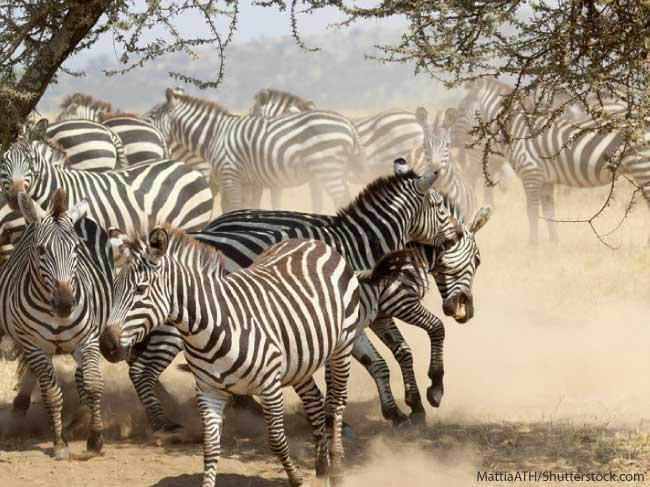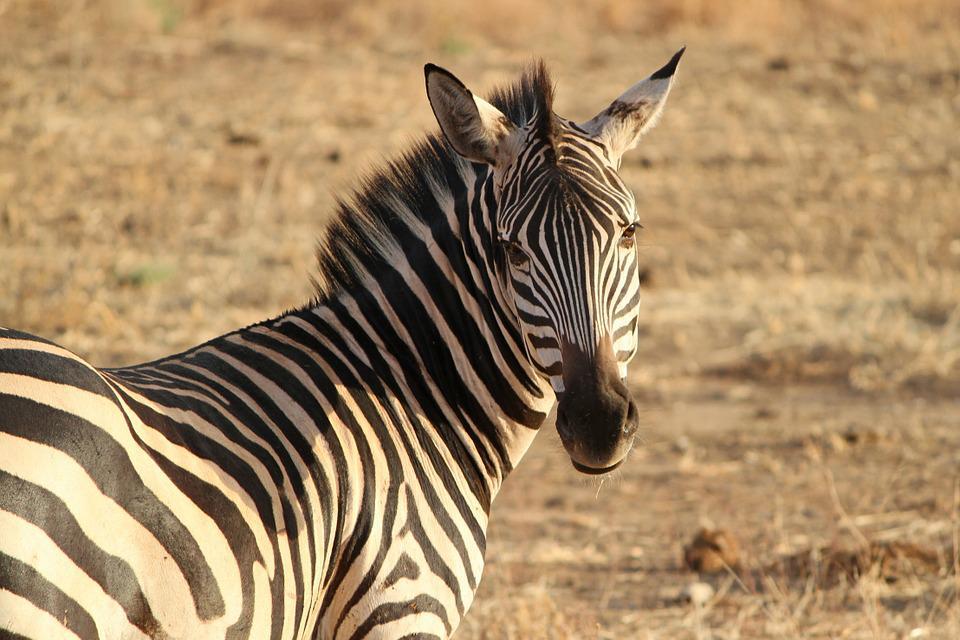The first image is the image on the left, the second image is the image on the right. For the images shown, is this caption "Two zebras are standing in the grass in at least one of the images." true? Answer yes or no. No. The first image is the image on the left, the second image is the image on the right. For the images displayed, is the sentence "The left image shows a standing zebra colt with upright head next to a standing adult zebra with its head lowered to graze." factually correct? Answer yes or no. No. 